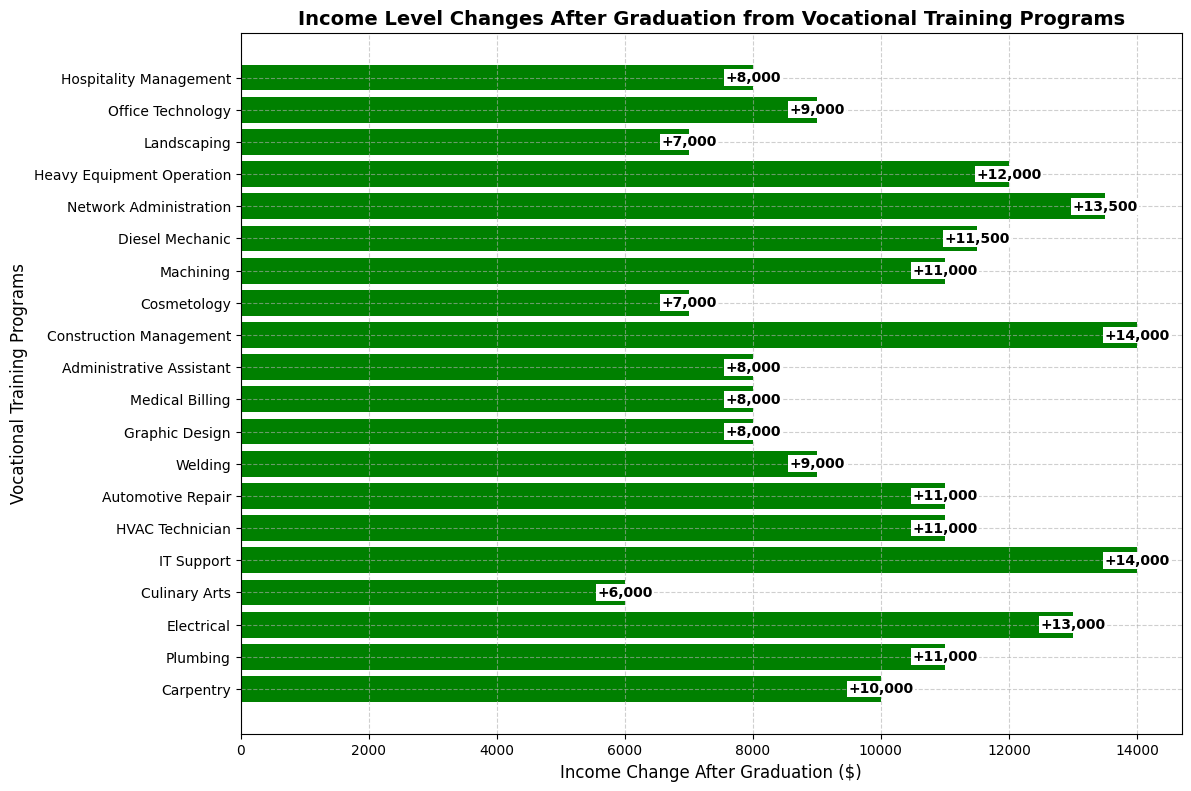Which vocational training program shows the greatest increase in income after graduation? The bar that extends the furthest to the right represents the greatest increase. In this case, it is Electrical.
Answer: Electrical Which program shows the least increase in income? The bar that extends the shortest to the right represents the smallest increase. This is Cosmetology.
Answer: Cosmetology How many programs result in an income increase of at least $15,000? Count the bars that extend to at least $15,000. These are Carpentry, Plumbing, Electrical, IT Support, HVAC Technician, Construction Management, Machining, Diesel Mechanic, Network Administration, and Heavy Equipment Operation. There are 10 such programs.
Answer: 10 Which programs show an increase in income of more than $20,000? Find the bars that extend beyond $20,000. These are Electrical, IT Support, Construction Management, Network Administration, and Heavy Equipment Operation.
Answer: Electrical, IT Support, Construction Management, Network Administration, Heavy Equipment Operation What is the average income increase across all programs? Sum each program's income increase and divide by the total number of programs. The income changes are as follows: 10000+11000+13000+6000+14000+11000+11000+9000+8000+8000+8000+14000+7000+11000+11500+13500+12000+7000+9000+8000. The sum is 198000. Dividing by 20 programs, the average increase is 198000/20 = 9900.
Answer: 9900 Which program has an income increase closest to the average increase? Compare each program’s increase to the average of $9900. The data points closest to this value are Carpentry ($10000) and Plumbing ($11000).
Answer: Carpentry Compare the income increase of Electrical and IT Support programs. Which one has a higher increase? The bar for Electrical extends to $13000, while the bar for IT Support extends to $14000. IT Support has a higher increase.
Answer: IT Support What percentage increase does the Carpentry program have relative to its initial income? The initial income for Carpentry is $25,000, and the increase is $10,000. The percentage increase is (10000/25000)*100 = 40%.
Answer: 40% Are there any programs with a negative income change after graduation? Look for any bars extending to the left. None of the bars extend to the left, indicating all programs have positive income changes.
Answer: No What is the combined income increase for Culinary Arts, Medical Billing, and Office Technology? The increases for these programs are $6000 for Culinary Arts, $8000 for Medical Billing, and $9000 for Office Technology. Summing these: 6000+8000+9000 = $23000.
Answer: 23000 